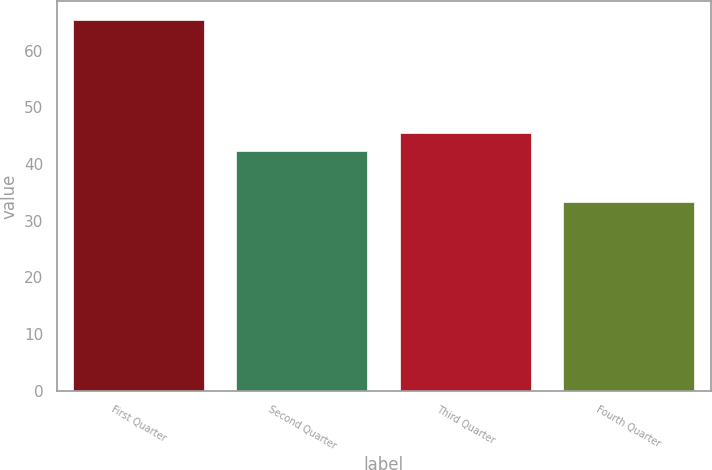<chart> <loc_0><loc_0><loc_500><loc_500><bar_chart><fcel>First Quarter<fcel>Second Quarter<fcel>Third Quarter<fcel>Fourth Quarter<nl><fcel>65.44<fcel>42.24<fcel>45.45<fcel>33.3<nl></chart> 